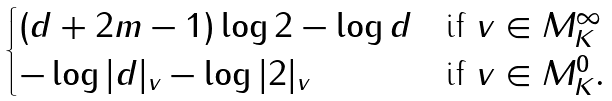<formula> <loc_0><loc_0><loc_500><loc_500>\begin{cases} ( d + 2 m - 1 ) \log 2 - \log d & \text {if } v \in M _ { K } ^ { \infty } \\ - \log | d | _ { v } - \log | 2 | _ { v } & \text {if } v \in M _ { K } ^ { 0 } . \end{cases}</formula> 